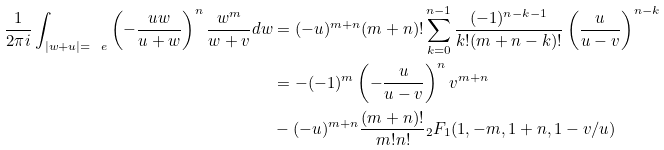<formula> <loc_0><loc_0><loc_500><loc_500>\frac { 1 } { 2 \pi i } \int _ { | w + u | = \ e } \left ( - \frac { u w } { u + w } \right ) ^ { n } \frac { w ^ { m } } { w + v } d w & = ( - u ) ^ { m + n } ( m + n ) ! \sum _ { k = 0 } ^ { n - 1 } \frac { ( - 1 ) ^ { n - k - 1 } } { k ! ( m + n - k ) ! } \left ( \frac { u } { u - v } \right ) ^ { n - k } \\ & = - ( - 1 ) ^ { m } \left ( - \frac { u } { u - v } \right ) ^ { n } v ^ { m + n } \\ & - ( - u ) ^ { m + n } \frac { ( m + n ) ! } { m ! n ! } { _ { 2 } F _ { 1 } ( 1 , - m , 1 + n , 1 - v / u ) }</formula> 